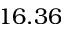Convert formula to latex. <formula><loc_0><loc_0><loc_500><loc_500>1 6 . 3 6</formula> 